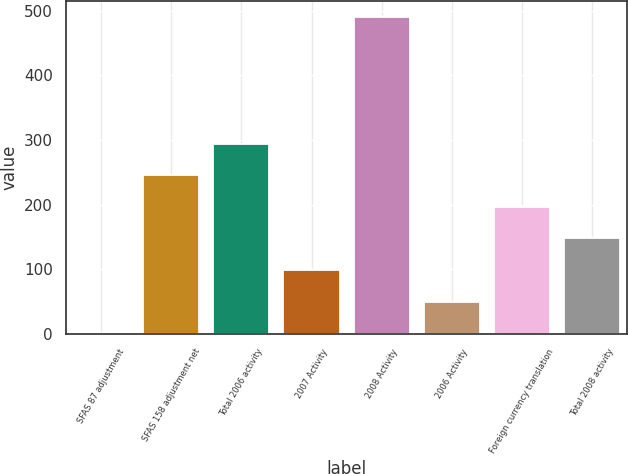Convert chart to OTSL. <chart><loc_0><loc_0><loc_500><loc_500><bar_chart><fcel>SFAS 87 adjustment<fcel>SFAS 158 adjustment net<fcel>Total 2006 activity<fcel>2007 Activity<fcel>2008 Activity<fcel>2006 Activity<fcel>Foreign currency translation<fcel>Total 2008 activity<nl><fcel>1<fcel>245.5<fcel>294.4<fcel>98.8<fcel>490<fcel>49.9<fcel>196.6<fcel>147.7<nl></chart> 